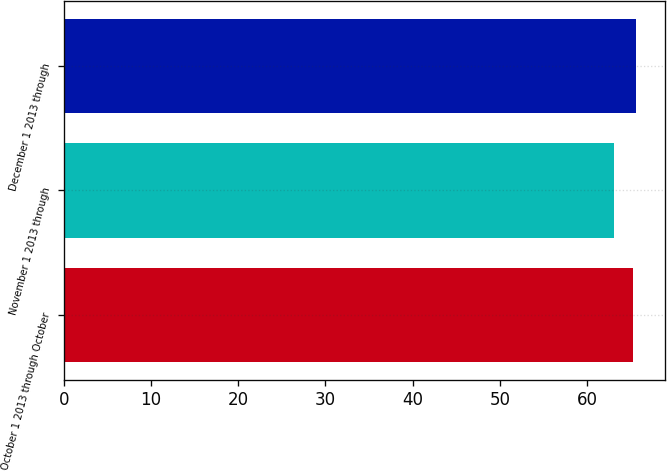Convert chart to OTSL. <chart><loc_0><loc_0><loc_500><loc_500><bar_chart><fcel>October 1 2013 through October<fcel>November 1 2013 through<fcel>December 1 2013 through<nl><fcel>65.33<fcel>63.13<fcel>65.68<nl></chart> 